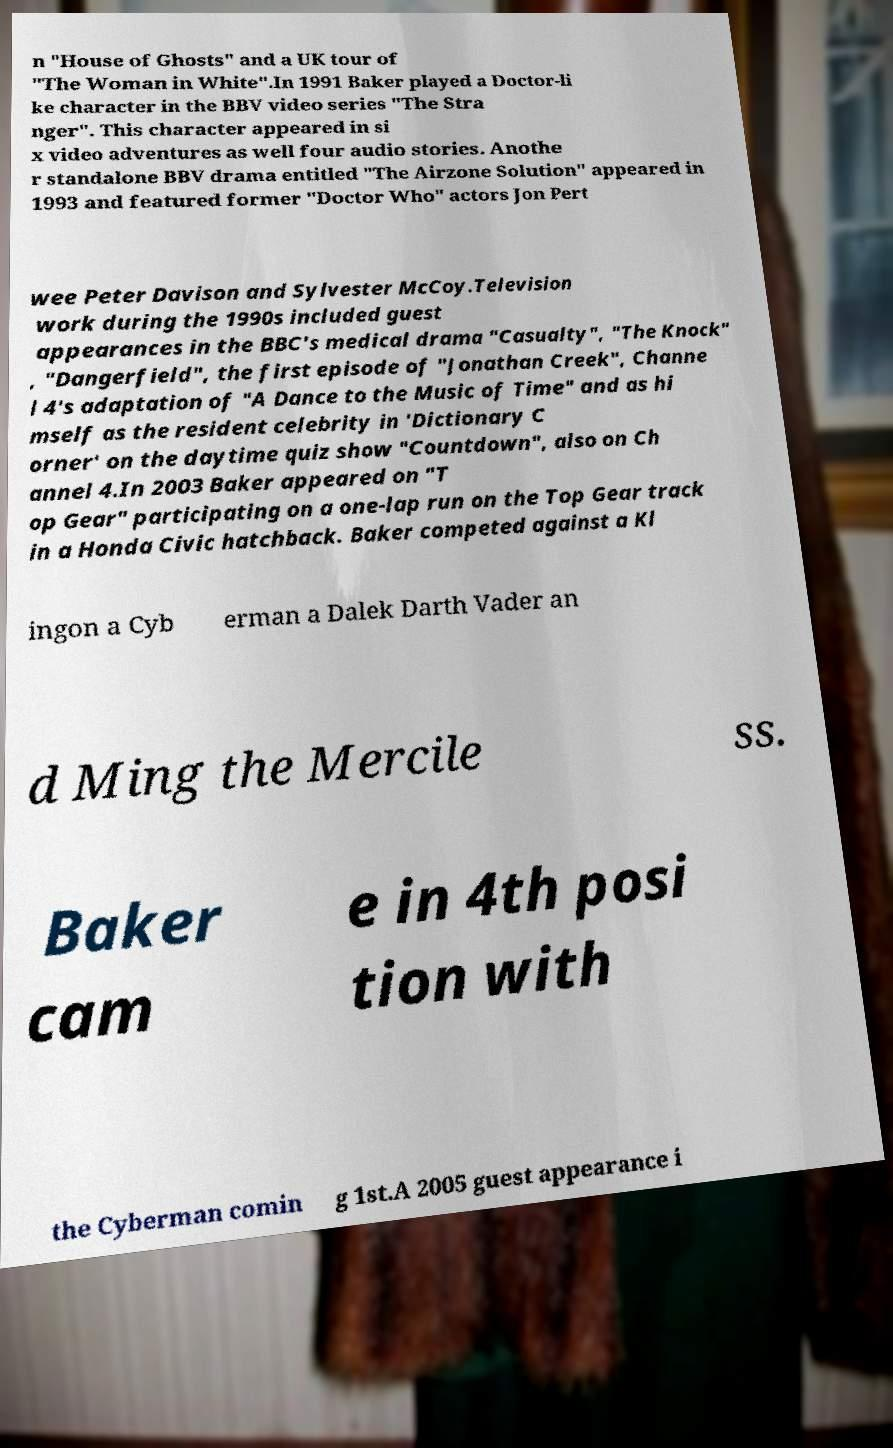Could you assist in decoding the text presented in this image and type it out clearly? n "House of Ghosts" and a UK tour of "The Woman in White".In 1991 Baker played a Doctor-li ke character in the BBV video series "The Stra nger". This character appeared in si x video adventures as well four audio stories. Anothe r standalone BBV drama entitled "The Airzone Solution" appeared in 1993 and featured former "Doctor Who" actors Jon Pert wee Peter Davison and Sylvester McCoy.Television work during the 1990s included guest appearances in the BBC's medical drama "Casualty", "The Knock" , "Dangerfield", the first episode of "Jonathan Creek", Channe l 4's adaptation of "A Dance to the Music of Time" and as hi mself as the resident celebrity in 'Dictionary C orner' on the daytime quiz show "Countdown", also on Ch annel 4.In 2003 Baker appeared on "T op Gear" participating on a one-lap run on the Top Gear track in a Honda Civic hatchback. Baker competed against a Kl ingon a Cyb erman a Dalek Darth Vader an d Ming the Mercile ss. Baker cam e in 4th posi tion with the Cyberman comin g 1st.A 2005 guest appearance i 